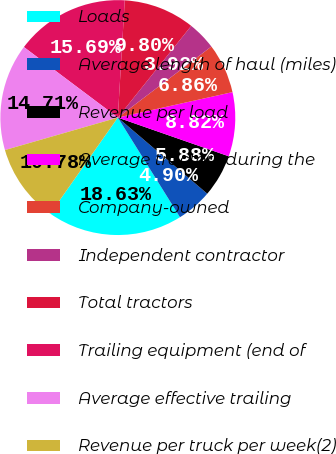<chart> <loc_0><loc_0><loc_500><loc_500><pie_chart><fcel>Loads<fcel>Average length of haul (miles)<fcel>Revenue per load<fcel>Average tractors during the<fcel>Company-owned<fcel>Independent contractor<fcel>Total tractors<fcel>Trailing equipment (end of<fcel>Average effective trailing<fcel>Revenue per truck per week(2)<nl><fcel>18.63%<fcel>4.9%<fcel>5.88%<fcel>8.82%<fcel>6.86%<fcel>3.92%<fcel>9.8%<fcel>15.69%<fcel>14.71%<fcel>10.78%<nl></chart> 